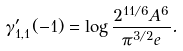Convert formula to latex. <formula><loc_0><loc_0><loc_500><loc_500>\gamma ^ { \prime } _ { 1 , 1 } ( - 1 ) = \log \frac { 2 ^ { 1 1 / 6 } A ^ { 6 } } { \pi ^ { 3 / 2 } e } .</formula> 